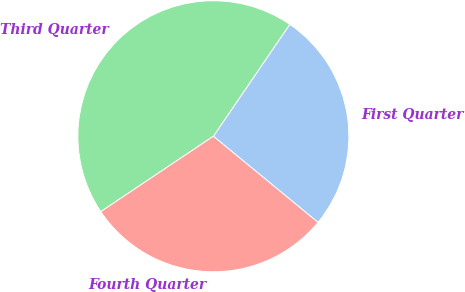Convert chart. <chart><loc_0><loc_0><loc_500><loc_500><pie_chart><fcel>First Quarter<fcel>Third Quarter<fcel>Fourth Quarter<nl><fcel>26.43%<fcel>43.93%<fcel>29.64%<nl></chart> 